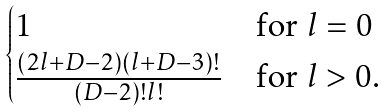<formula> <loc_0><loc_0><loc_500><loc_500>\begin{cases} 1 & \text {for $l=0$} \\ \frac { ( 2 l + D - 2 ) ( l + D - 3 ) ! } { ( D - 2 ) ! l ! } & \text {for $l>0$.} \end{cases}</formula> 